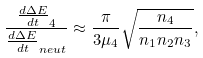Convert formula to latex. <formula><loc_0><loc_0><loc_500><loc_500>\frac { \frac { d \Delta E } { d t } _ { 4 } } { \frac { d \Delta E } { d t } _ { n e u t } } \approx \frac { \pi } { 3 \mu _ { 4 } } \sqrt { \frac { n _ { 4 } } { n _ { 1 } n _ { 2 } n _ { 3 } } } ,</formula> 